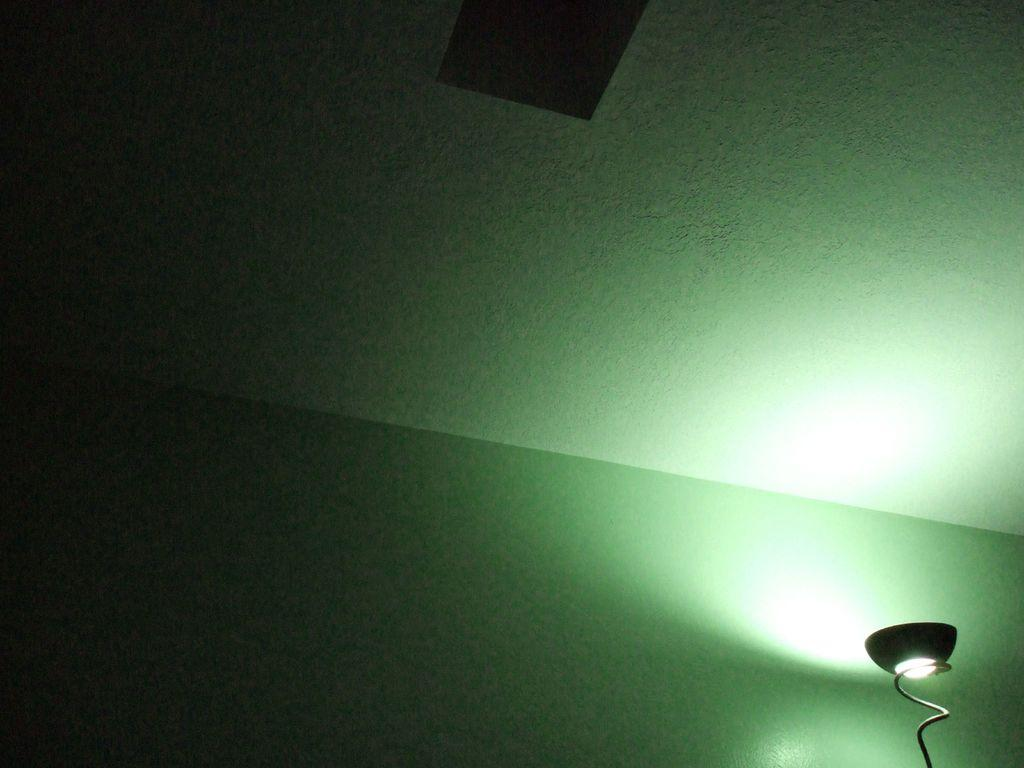What part of the room can be seen in the image? The ceiling is visible in the image. What type of lighting is present in the image? There is a light with a stand in the image. What color is the wall in the image? The wall is painted with green paint. What size is the surprise in the image? There is no surprise present in the image, so it is not possible to determine its size. 